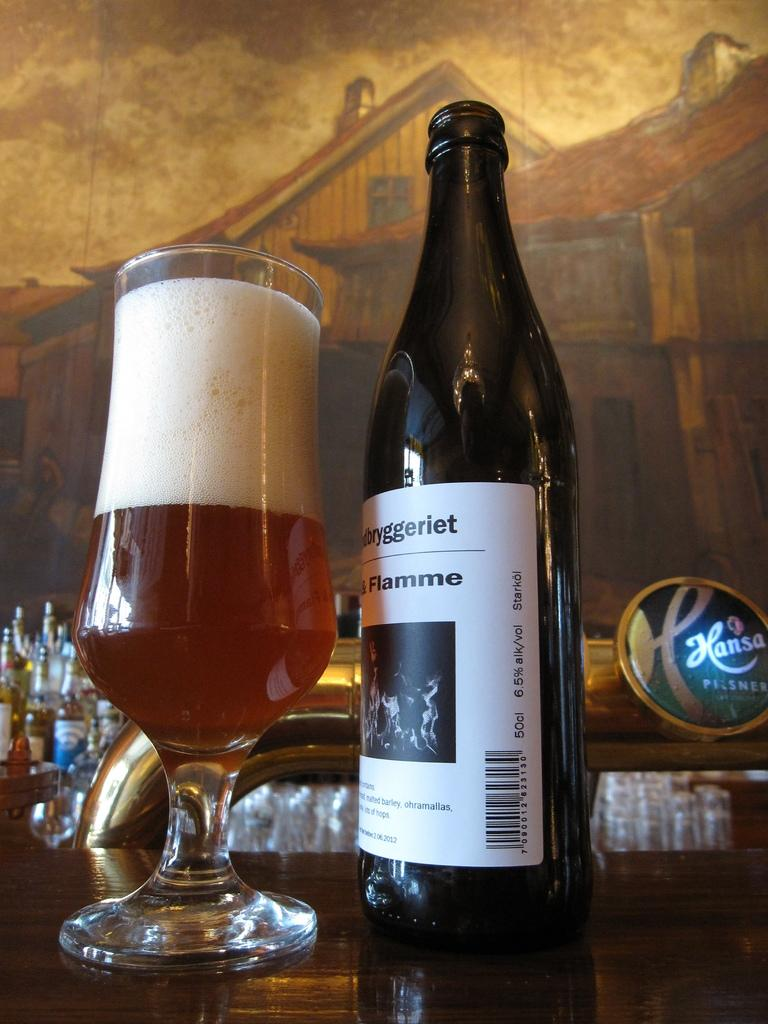What objects are in the foreground of the image? There is a bottle and a glass in the foreground of the image. What is inside the glass? There is a drink in the glass. What can be seen in the background of the image? There are bottles in the background of the image. What piece of furniture is at the bottom of the image? There is a table at the bottom of the image. What type of body is visible in the image? There is no body present in the image; it only features bottles, a glass, a drink, and a table. What kind of bubble can be seen floating in the image? There are no bubbles present in the image. 